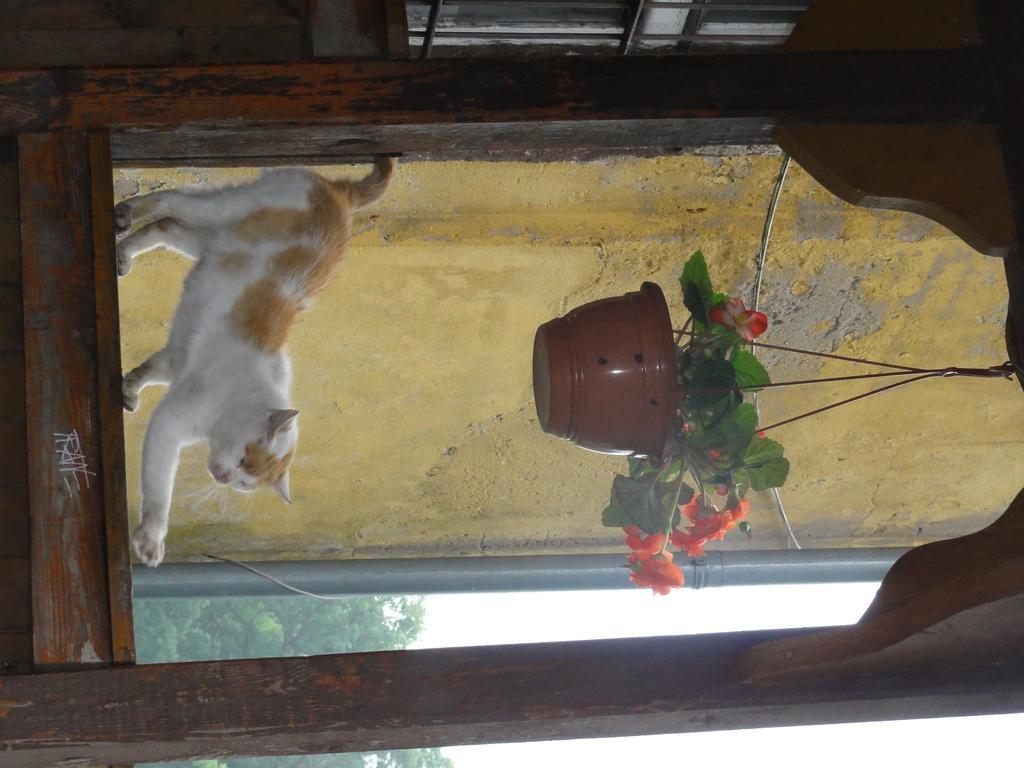Describe this image in one or two sentences. In this image is there is a cat on the window. A pot is hanging from the window. The pot is having a plant which is having flowers and leaves. From the window a wall, trees and sky are visible. 